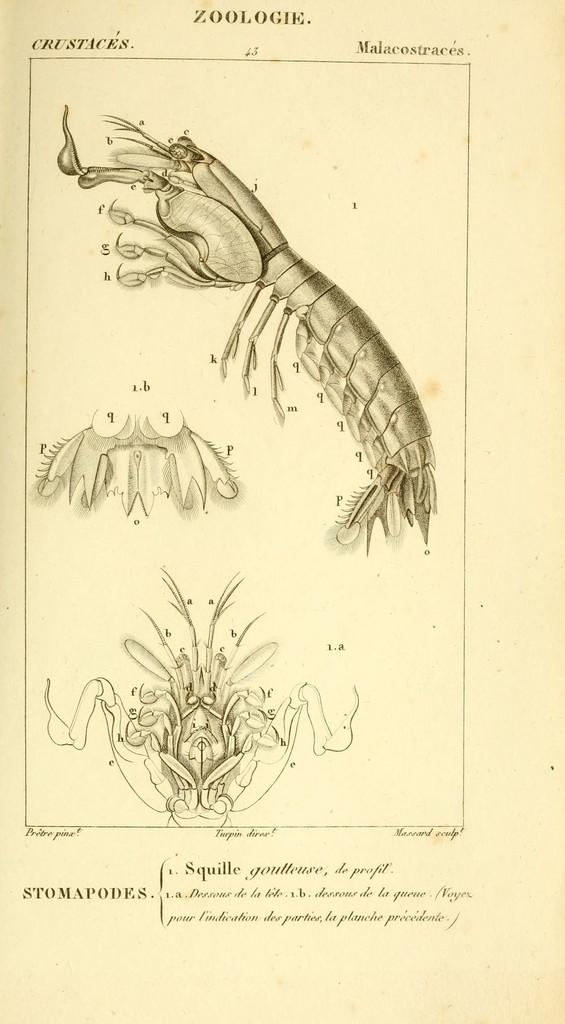What is the main object in the image? There is a card in the image. What is depicted on the card? The card has a drawing of an animal. Is there any text on the card? Yes, there is text at the bottom of the card. Can you see a crown on the animal's head in the image? There is no crown visible on the animal's head in the image. Is there a pen used to draw the animal on the card? The facts provided do not mention a pen or any drawing tools, so we cannot determine how the animal was drawn on the card. 